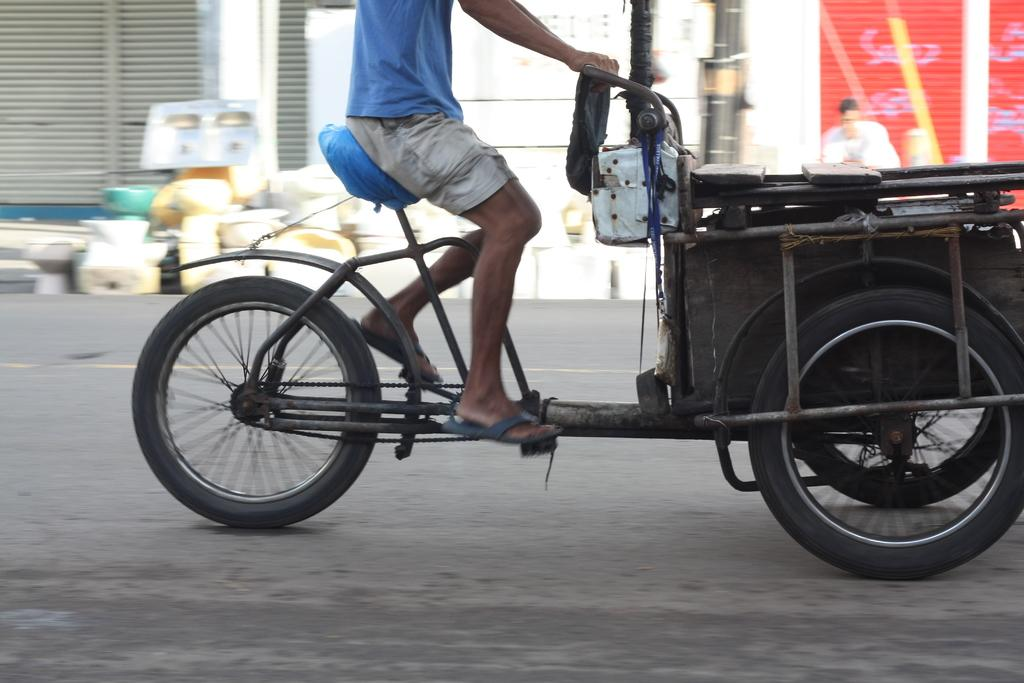What is the main subject of the image? There is a person on a vehicle in the image. Where is the vehicle located? The vehicle is on the road. Can you describe the background of the image? There is a person, shutters, and some objects visible in the background of the image. What type of fire can be seen in the image? There is no fire present in the image. Is there an arch visible in the image? There is no arch visible in the image. 